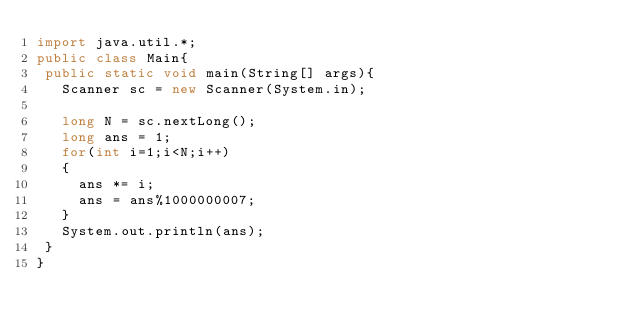Convert code to text. <code><loc_0><loc_0><loc_500><loc_500><_Java_>import java.util.*;
public class Main{
 public static void main(String[] args){
   Scanner sc = new Scanner(System.in);
 
   long N = sc.nextLong();
   long ans = 1;
   for(int i=1;i<N;i++) 
   {
     ans *= i;
     ans = ans%1000000007;
   }
   System.out.println(ans);
 }
}</code> 